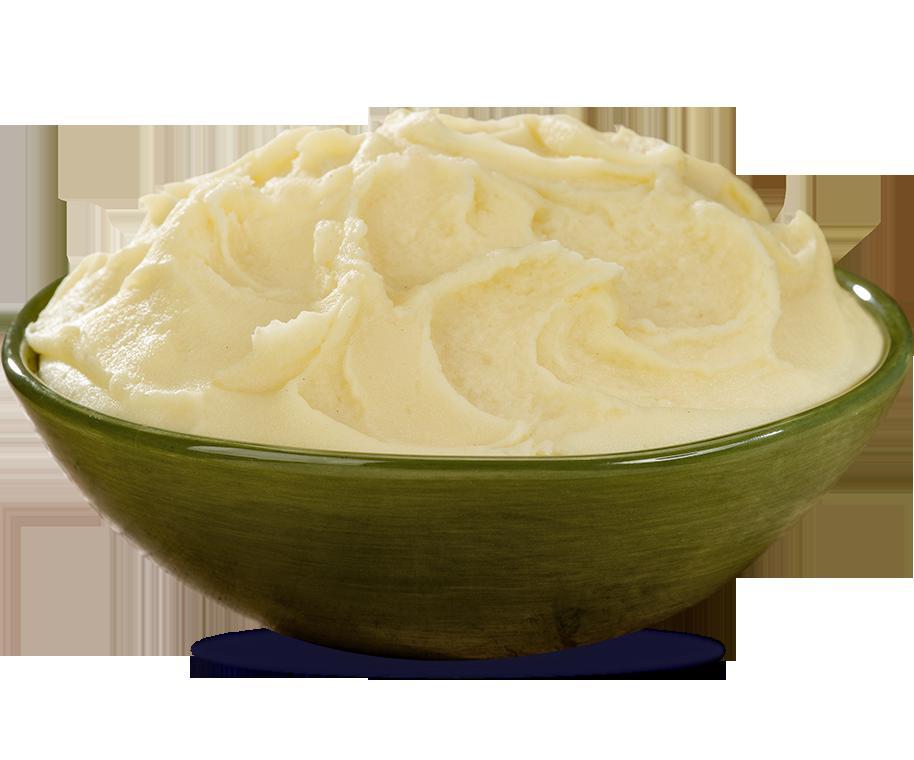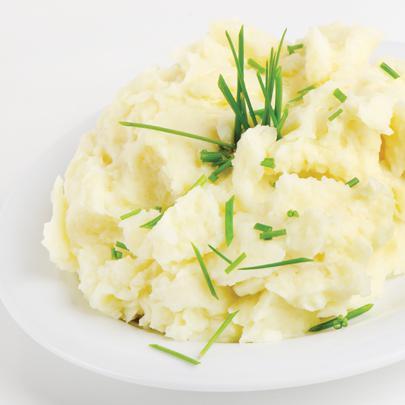The first image is the image on the left, the second image is the image on the right. Examine the images to the left and right. Is the description "One image shows mashed potatoes on a squarish plate garnished with green sprig." accurate? Answer yes or no. No. 